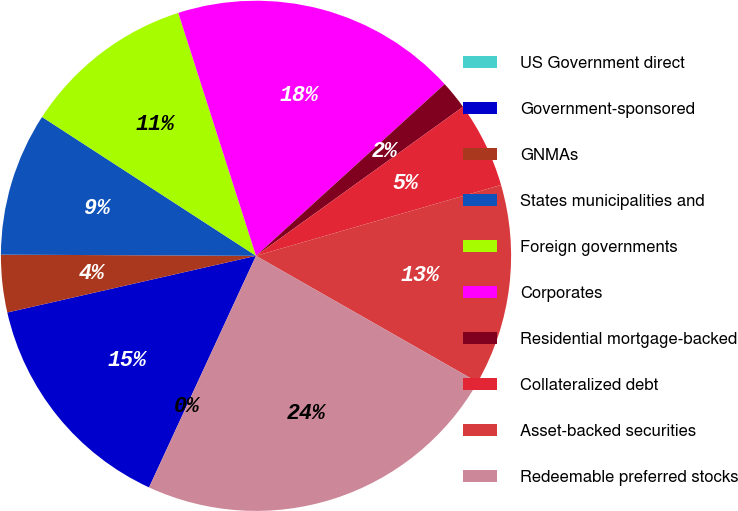Convert chart. <chart><loc_0><loc_0><loc_500><loc_500><pie_chart><fcel>US Government direct<fcel>Government-sponsored<fcel>GNMAs<fcel>States municipalities and<fcel>Foreign governments<fcel>Corporates<fcel>Residential mortgage-backed<fcel>Collateralized debt<fcel>Asset-backed securities<fcel>Redeemable preferred stocks<nl><fcel>0.0%<fcel>14.55%<fcel>3.64%<fcel>9.09%<fcel>10.91%<fcel>18.18%<fcel>1.82%<fcel>5.45%<fcel>12.73%<fcel>23.64%<nl></chart> 